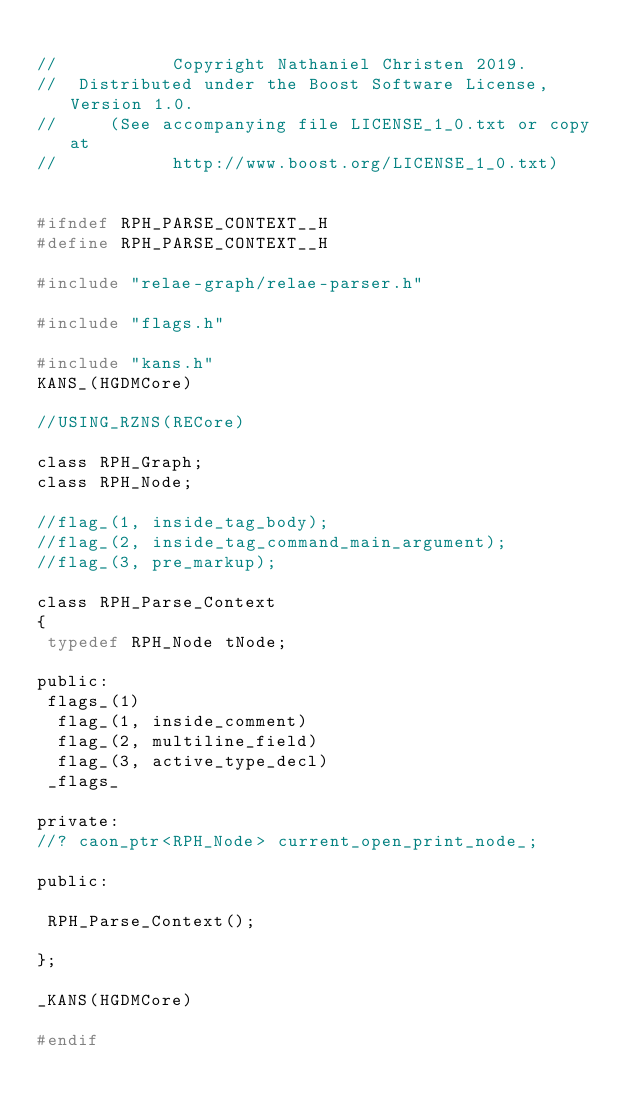<code> <loc_0><loc_0><loc_500><loc_500><_C_>
//           Copyright Nathaniel Christen 2019.
//  Distributed under the Boost Software License, Version 1.0.
//     (See accompanying file LICENSE_1_0.txt or copy at
//           http://www.boost.org/LICENSE_1_0.txt)


#ifndef RPH_PARSE_CONTEXT__H
#define RPH_PARSE_CONTEXT__H

#include "relae-graph/relae-parser.h"

#include "flags.h"

#include "kans.h"
KANS_(HGDMCore)

//USING_RZNS(RECore)

class RPH_Graph;
class RPH_Node;

//flag_(1, inside_tag_body);
//flag_(2, inside_tag_command_main_argument);
//flag_(3, pre_markup);

class RPH_Parse_Context
{
 typedef RPH_Node tNode;

public:
 flags_(1)
  flag_(1, inside_comment)
  flag_(2, multiline_field)
  flag_(3, active_type_decl)
 _flags_

private:
//? caon_ptr<RPH_Node> current_open_print_node_;

public:

 RPH_Parse_Context();

};

_KANS(HGDMCore)

#endif
</code> 